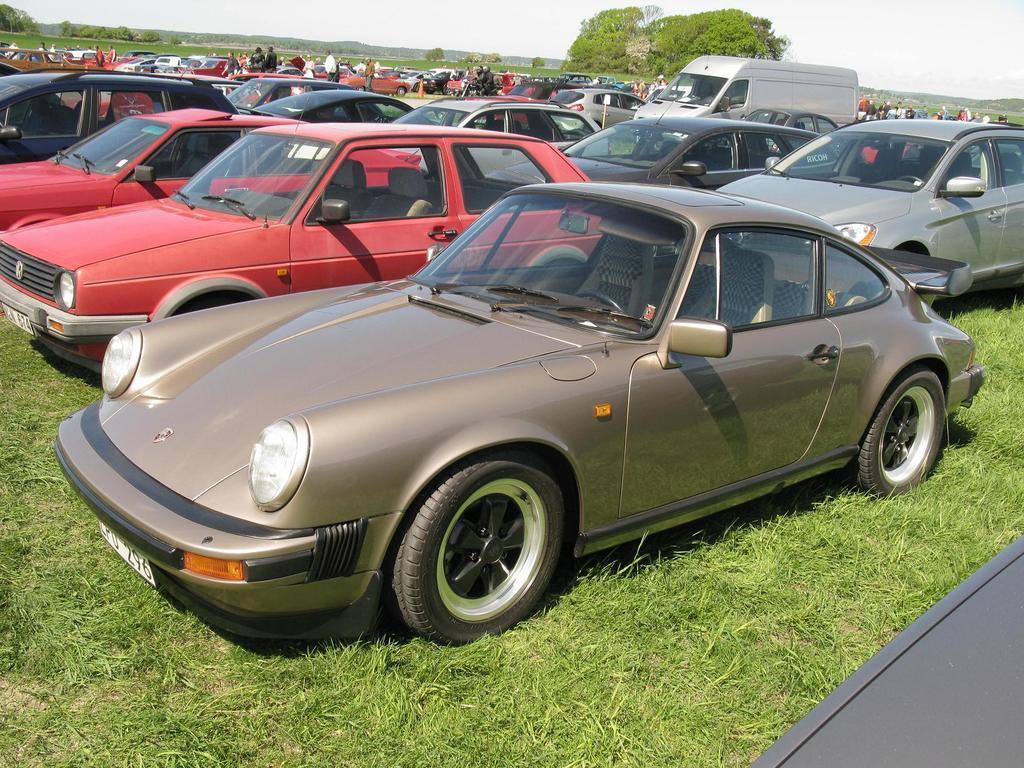Can you describe this image briefly? In this image we can see vehicles and few people on the grass. In the background there are trees and sky. 